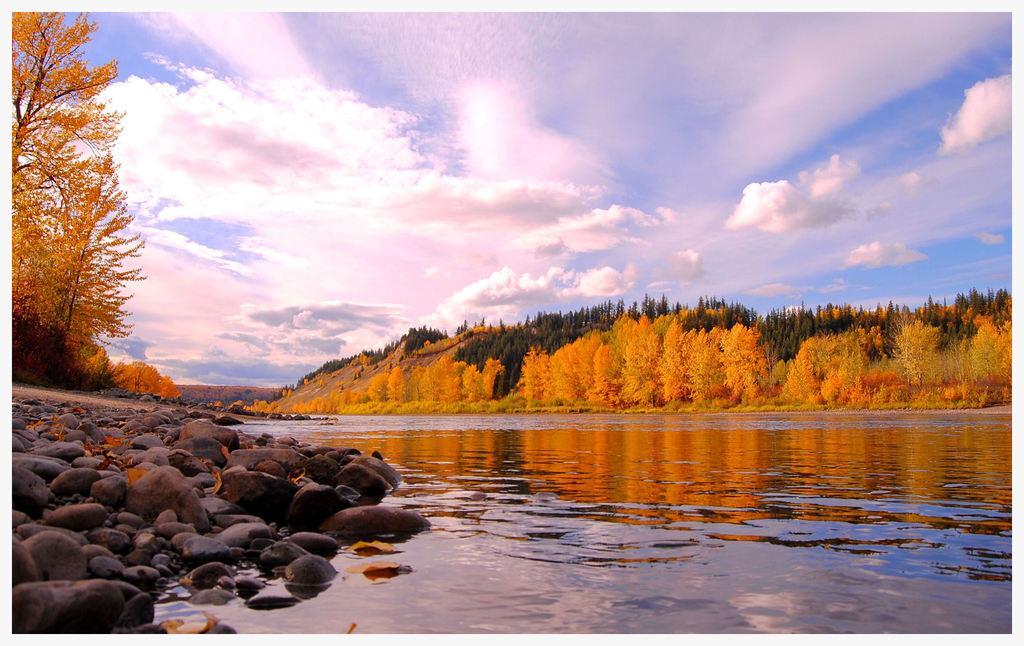How would you summarize this image in a sentence or two? In this image, we can see so many trees, plants, stones and water. Background we can see the cloudy sky. 